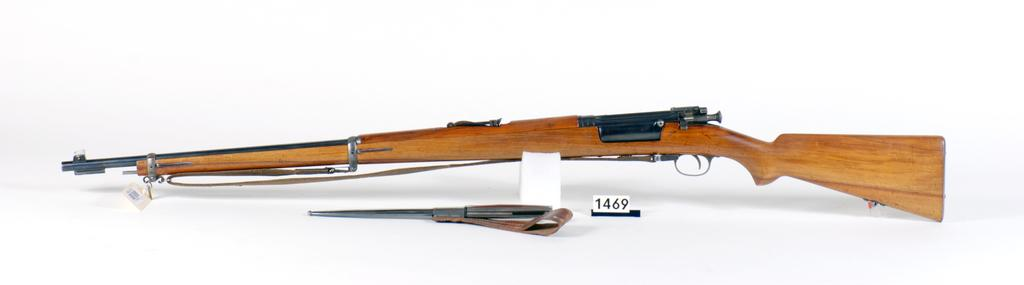What type of weapons are present in the image? There is a gun and a rifle in the image. Where are the gun and the rifle located in the image? Both the gun and the rifle are placed on a surface in the image. What theory is being discussed in the image? There is no discussion or theory present in the image; it features a gun and a rifle placed on a surface. Can you see any wings on the gun or the rifle in the image? No, there are no wings on the gun or the rifle in the image. 